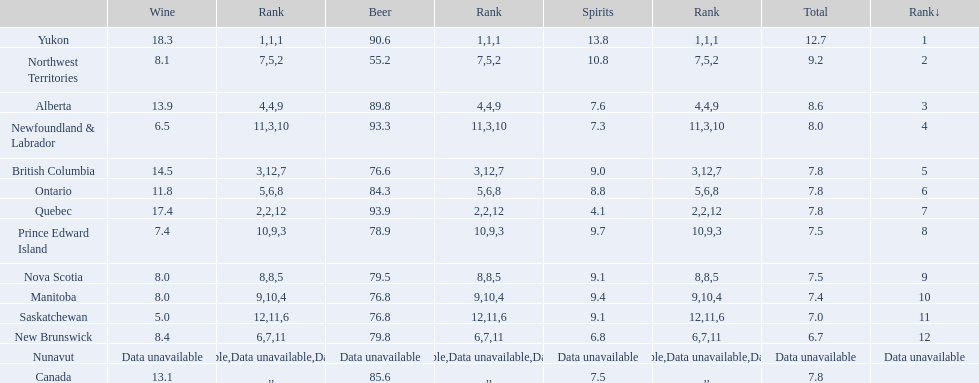Indicate the province that had a wine consumption exceeding 15 liters. Yukon, Quebec. 